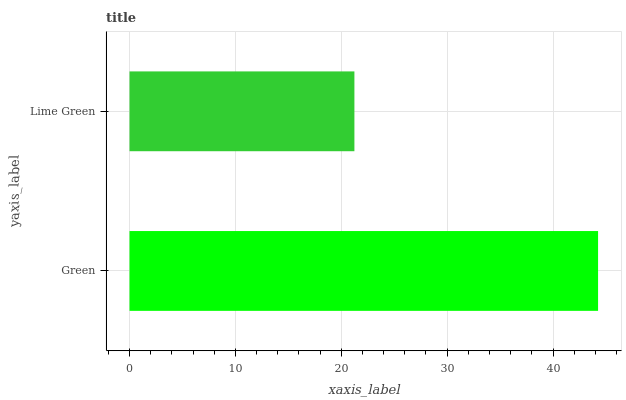Is Lime Green the minimum?
Answer yes or no. Yes. Is Green the maximum?
Answer yes or no. Yes. Is Lime Green the maximum?
Answer yes or no. No. Is Green greater than Lime Green?
Answer yes or no. Yes. Is Lime Green less than Green?
Answer yes or no. Yes. Is Lime Green greater than Green?
Answer yes or no. No. Is Green less than Lime Green?
Answer yes or no. No. Is Green the high median?
Answer yes or no. Yes. Is Lime Green the low median?
Answer yes or no. Yes. Is Lime Green the high median?
Answer yes or no. No. Is Green the low median?
Answer yes or no. No. 